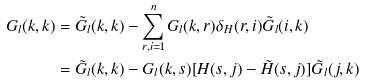Convert formula to latex. <formula><loc_0><loc_0><loc_500><loc_500>G _ { l } ( k , k ) & = \tilde { G } _ { l } ( k , k ) - \sum _ { r , i = 1 } ^ { n } G _ { l } ( k , r ) \delta _ { H } ( r , i ) \tilde { G } _ { l } ( i , k ) \\ & = \tilde { G } _ { l } ( k , k ) - G _ { l } ( k , s ) [ H ( s , j ) - \tilde { H } ( s , j ) ] \tilde { G } _ { l } ( j , k )</formula> 